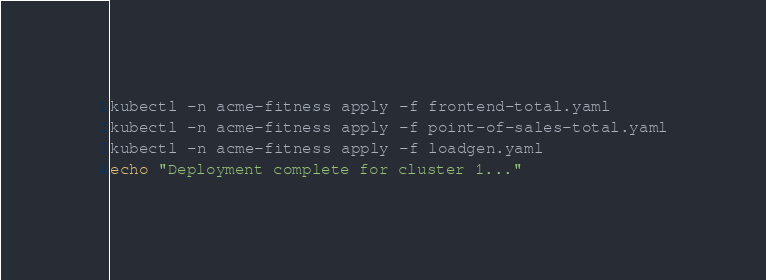Convert code to text. <code><loc_0><loc_0><loc_500><loc_500><_Bash_>kubectl -n acme-fitness apply -f frontend-total.yaml
kubectl -n acme-fitness apply -f point-of-sales-total.yaml
kubectl -n acme-fitness apply -f loadgen.yaml
echo "Deployment complete for cluster 1..."
</code> 